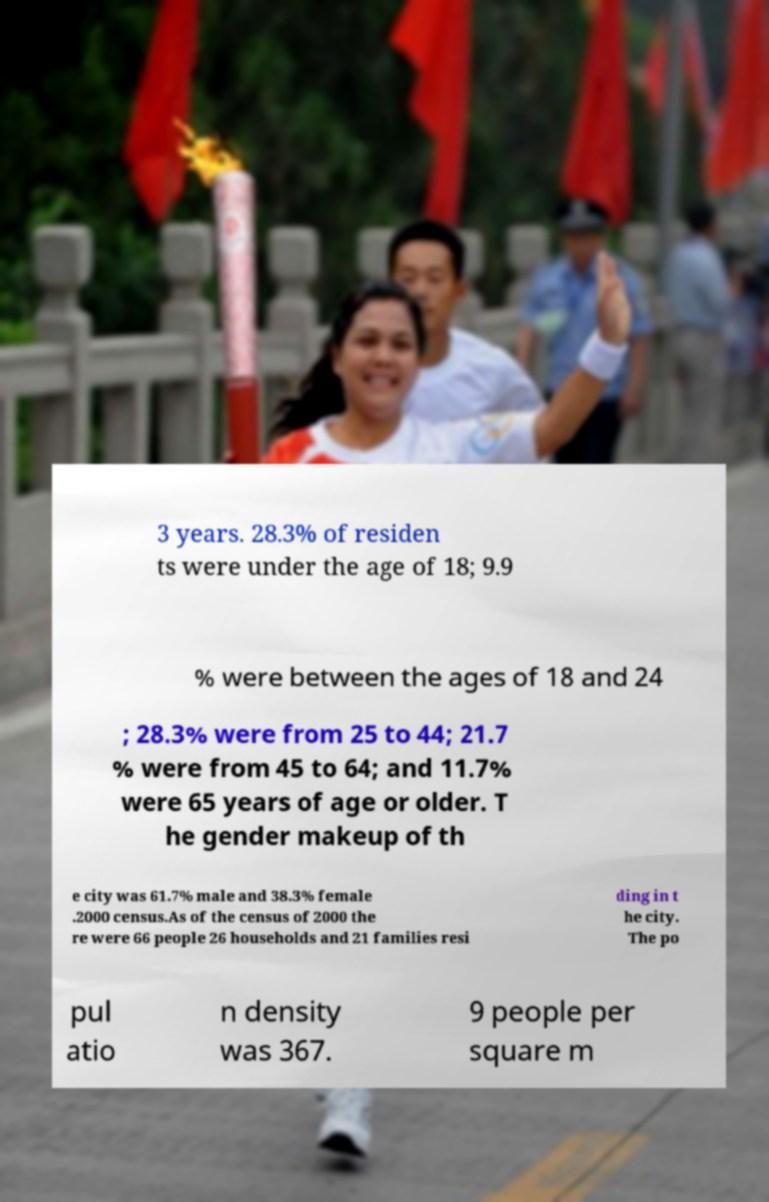Could you extract and type out the text from this image? 3 years. 28.3% of residen ts were under the age of 18; 9.9 % were between the ages of 18 and 24 ; 28.3% were from 25 to 44; 21.7 % were from 45 to 64; and 11.7% were 65 years of age or older. T he gender makeup of th e city was 61.7% male and 38.3% female .2000 census.As of the census of 2000 the re were 66 people 26 households and 21 families resi ding in t he city. The po pul atio n density was 367. 9 people per square m 